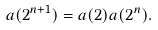<formula> <loc_0><loc_0><loc_500><loc_500>a ( 2 ^ { n + 1 } ) & = a ( 2 ) a ( 2 ^ { n } ) .</formula> 